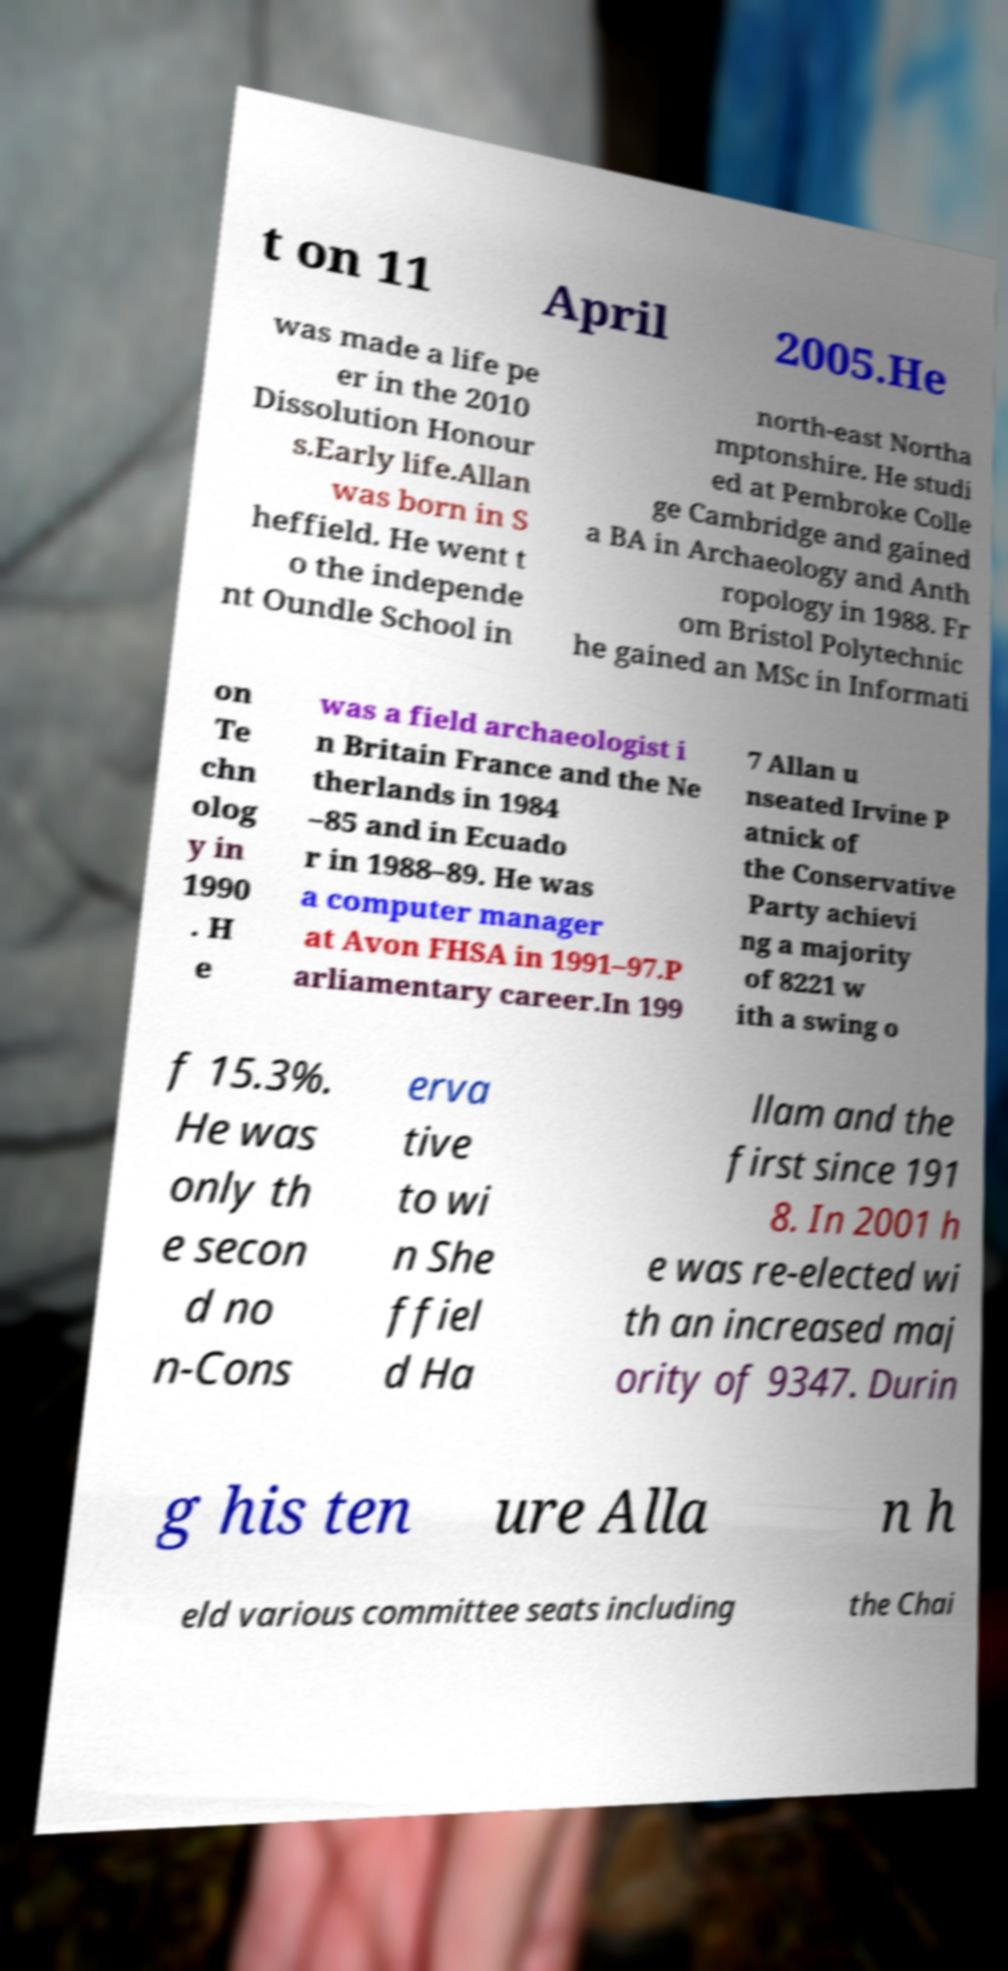Please read and relay the text visible in this image. What does it say? t on 11 April 2005.He was made a life pe er in the 2010 Dissolution Honour s.Early life.Allan was born in S heffield. He went t o the independe nt Oundle School in north-east Northa mptonshire. He studi ed at Pembroke Colle ge Cambridge and gained a BA in Archaeology and Anth ropology in 1988. Fr om Bristol Polytechnic he gained an MSc in Informati on Te chn olog y in 1990 . H e was a field archaeologist i n Britain France and the Ne therlands in 1984 –85 and in Ecuado r in 1988–89. He was a computer manager at Avon FHSA in 1991–97.P arliamentary career.In 199 7 Allan u nseated Irvine P atnick of the Conservative Party achievi ng a majority of 8221 w ith a swing o f 15.3%. He was only th e secon d no n-Cons erva tive to wi n She ffiel d Ha llam and the first since 191 8. In 2001 h e was re-elected wi th an increased maj ority of 9347. Durin g his ten ure Alla n h eld various committee seats including the Chai 